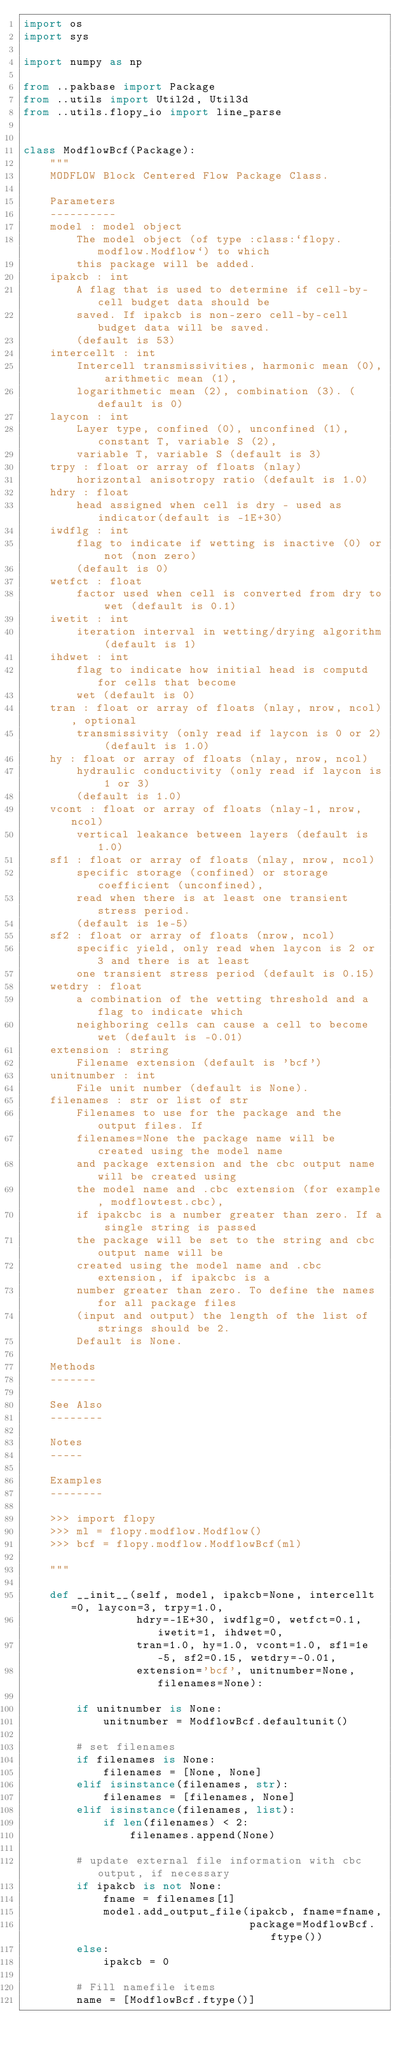<code> <loc_0><loc_0><loc_500><loc_500><_Python_>import os
import sys

import numpy as np

from ..pakbase import Package
from ..utils import Util2d, Util3d
from ..utils.flopy_io import line_parse


class ModflowBcf(Package):
    """
    MODFLOW Block Centered Flow Package Class.

    Parameters
    ----------
    model : model object
        The model object (of type :class:`flopy.modflow.Modflow`) to which
        this package will be added.
    ipakcb : int
        A flag that is used to determine if cell-by-cell budget data should be
        saved. If ipakcb is non-zero cell-by-cell budget data will be saved.
        (default is 53)
    intercellt : int
        Intercell transmissivities, harmonic mean (0), arithmetic mean (1),
        logarithmetic mean (2), combination (3). (default is 0)
    laycon : int
        Layer type, confined (0), unconfined (1), constant T, variable S (2),
        variable T, variable S (default is 3)
    trpy : float or array of floats (nlay)
        horizontal anisotropy ratio (default is 1.0)
    hdry : float
        head assigned when cell is dry - used as indicator(default is -1E+30)
    iwdflg : int
        flag to indicate if wetting is inactive (0) or not (non zero)
        (default is 0)
    wetfct : float
        factor used when cell is converted from dry to wet (default is 0.1)
    iwetit : int
        iteration interval in wetting/drying algorithm (default is 1)
    ihdwet : int
        flag to indicate how initial head is computd for cells that become
        wet (default is 0)
    tran : float or array of floats (nlay, nrow, ncol), optional
        transmissivity (only read if laycon is 0 or 2) (default is 1.0)
    hy : float or array of floats (nlay, nrow, ncol)
        hydraulic conductivity (only read if laycon is 1 or 3)
        (default is 1.0)
    vcont : float or array of floats (nlay-1, nrow, ncol)
        vertical leakance between layers (default is 1.0)
    sf1 : float or array of floats (nlay, nrow, ncol)
        specific storage (confined) or storage coefficient (unconfined),
        read when there is at least one transient stress period.
        (default is 1e-5)
    sf2 : float or array of floats (nrow, ncol)
        specific yield, only read when laycon is 2 or 3 and there is at least
        one transient stress period (default is 0.15)
    wetdry : float
        a combination of the wetting threshold and a flag to indicate which
        neighboring cells can cause a cell to become wet (default is -0.01)
    extension : string
        Filename extension (default is 'bcf')
    unitnumber : int
        File unit number (default is None).
    filenames : str or list of str
        Filenames to use for the package and the output files. If
        filenames=None the package name will be created using the model name
        and package extension and the cbc output name will be created using
        the model name and .cbc extension (for example, modflowtest.cbc),
        if ipakcbc is a number greater than zero. If a single string is passed
        the package will be set to the string and cbc output name will be
        created using the model name and .cbc extension, if ipakcbc is a
        number greater than zero. To define the names for all package files
        (input and output) the length of the list of strings should be 2.
        Default is None.

    Methods
    -------

    See Also
    --------

    Notes
    -----

    Examples
    --------

    >>> import flopy
    >>> ml = flopy.modflow.Modflow()
    >>> bcf = flopy.modflow.ModflowBcf(ml)

    """

    def __init__(self, model, ipakcb=None, intercellt=0, laycon=3, trpy=1.0,
                 hdry=-1E+30, iwdflg=0, wetfct=0.1, iwetit=1, ihdwet=0,
                 tran=1.0, hy=1.0, vcont=1.0, sf1=1e-5, sf2=0.15, wetdry=-0.01,
                 extension='bcf', unitnumber=None, filenames=None):

        if unitnumber is None:
            unitnumber = ModflowBcf.defaultunit()

        # set filenames
        if filenames is None:
            filenames = [None, None]
        elif isinstance(filenames, str):
            filenames = [filenames, None]
        elif isinstance(filenames, list):
            if len(filenames) < 2:
                filenames.append(None)

        # update external file information with cbc output, if necessary
        if ipakcb is not None:
            fname = filenames[1]
            model.add_output_file(ipakcb, fname=fname,
                                  package=ModflowBcf.ftype())
        else:
            ipakcb = 0

        # Fill namefile items
        name = [ModflowBcf.ftype()]</code> 